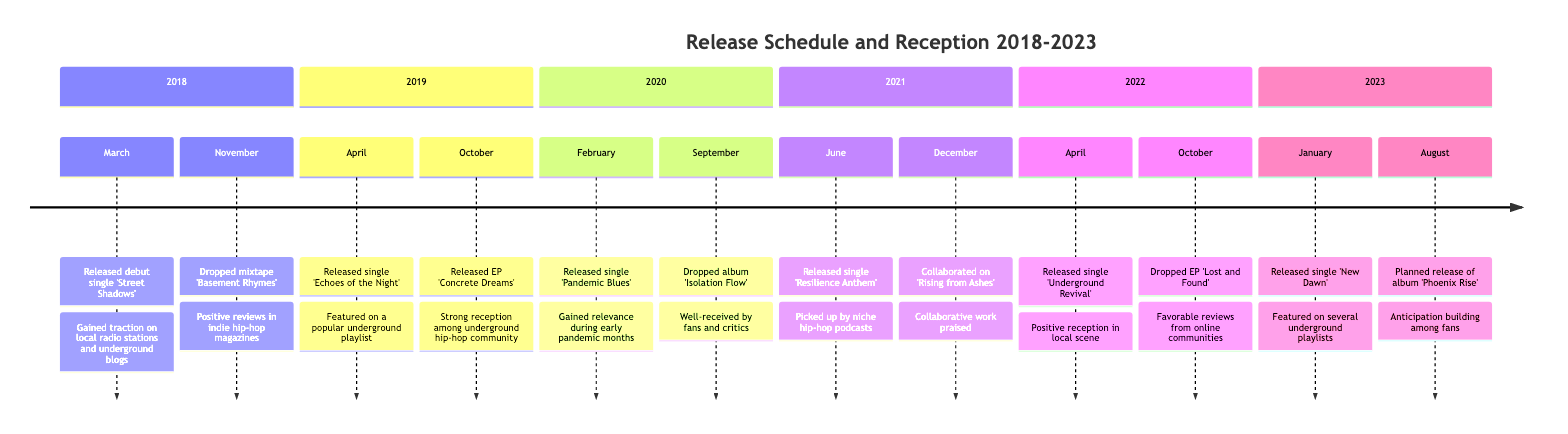What was the first single released in the timeline? The timeline lists the debut single 'Street Shadows' as the first event in March 2018.
Answer: Street Shadows How many events occurred in 2020? The timeline shows two events listed for the year 2020: the release of 'Pandemic Blues' and the album 'Isolation Flow'.
Answer: 2 Which event in 2021 received praise for collaborative work? The event in December 2021, where the single 'Rising from Ashes' was collaborated on with local artists, is noted for being praised.
Answer: Rising from Ashes In which month was 'Concrete Dreams' released? 'Concrete Dreams' was released in October 2019, as indicated in the events listed for that year.
Answer: October What was the reception of the album 'Isolation Flow'? The reception of 'Isolation Flow' is described as well-received by fans and critics. This evaluation is provided next to the event in September 2020.
Answer: Well-received Which year had a release called 'Underground Revival'? The timeline indicates that 'Underground Revival' was released in April 2022 according to the sequence of events listed for that year.
Answer: 2022 What significant impact did the single 'Pandemic Blues' have during its release? The single gained relevance during the early months of the pandemic but faced limited exposure due to the lockdown, highlighting the challenges of promotion at that time.
Answer: Gained relevance during pandemic How many months are covered in the timeline? The timeline spans six years from 2018 to 2023, with a total of multiple events listed, clearly marking events on a month-by-month basis across those years, indicating a broad array of activity.
Answer: 72 (months) 